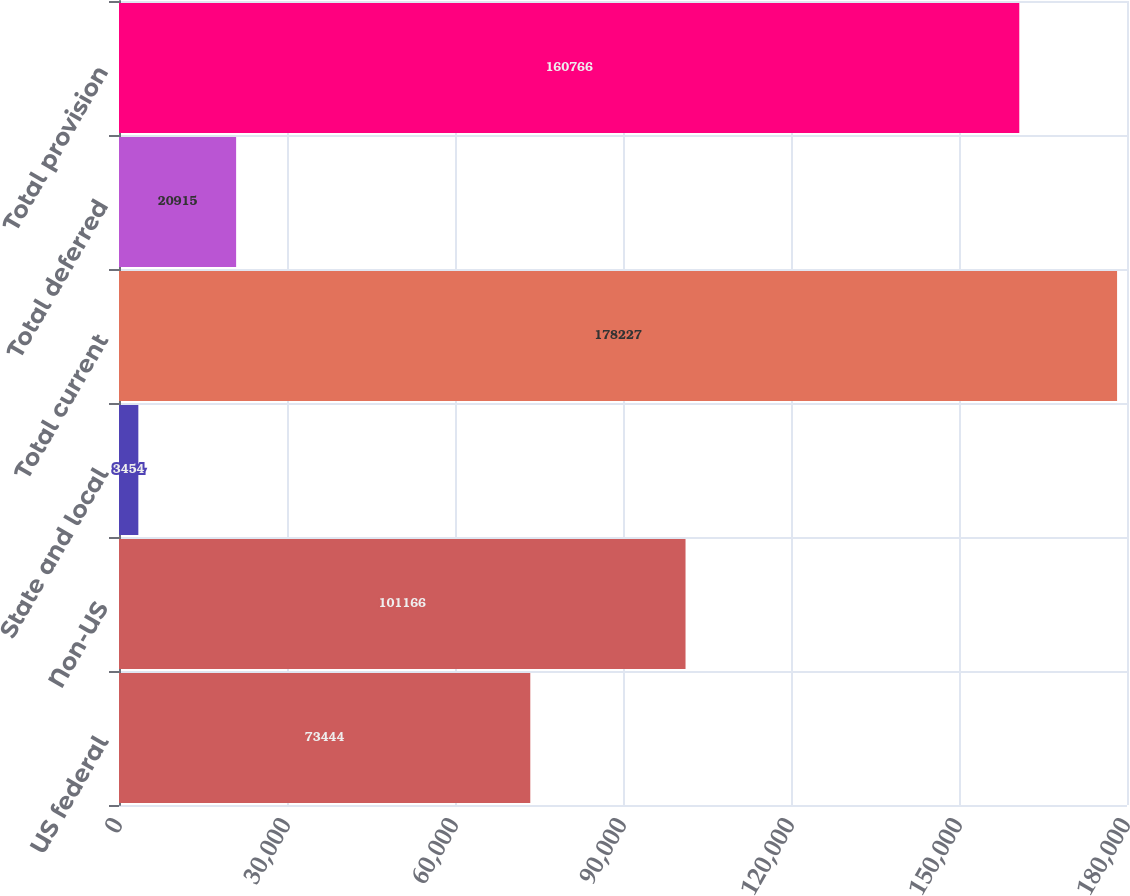Convert chart. <chart><loc_0><loc_0><loc_500><loc_500><bar_chart><fcel>US federal<fcel>Non-US<fcel>State and local<fcel>Total current<fcel>Total deferred<fcel>Total provision<nl><fcel>73444<fcel>101166<fcel>3454<fcel>178227<fcel>20915<fcel>160766<nl></chart> 